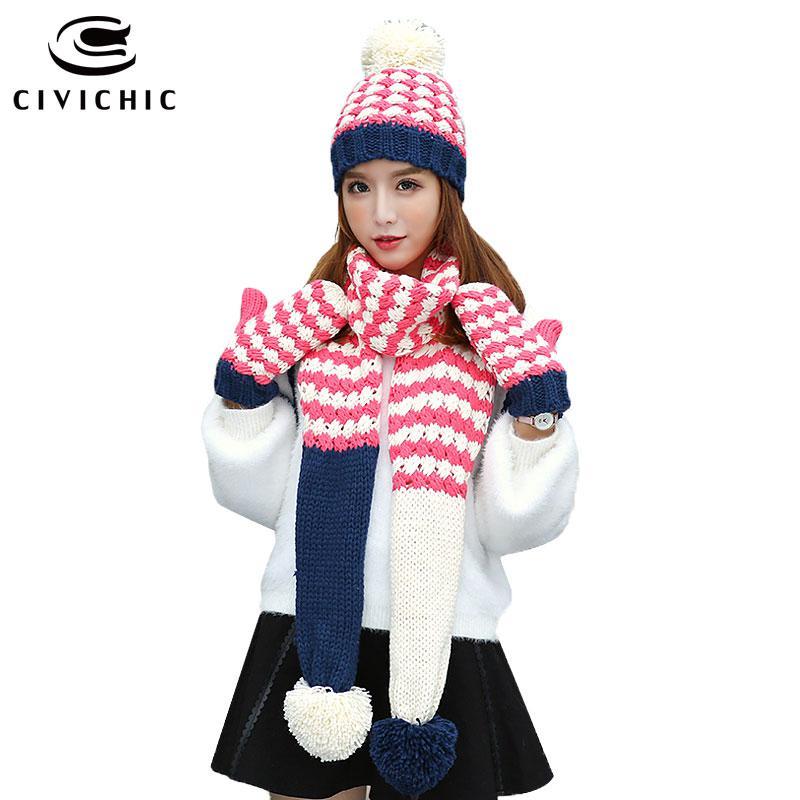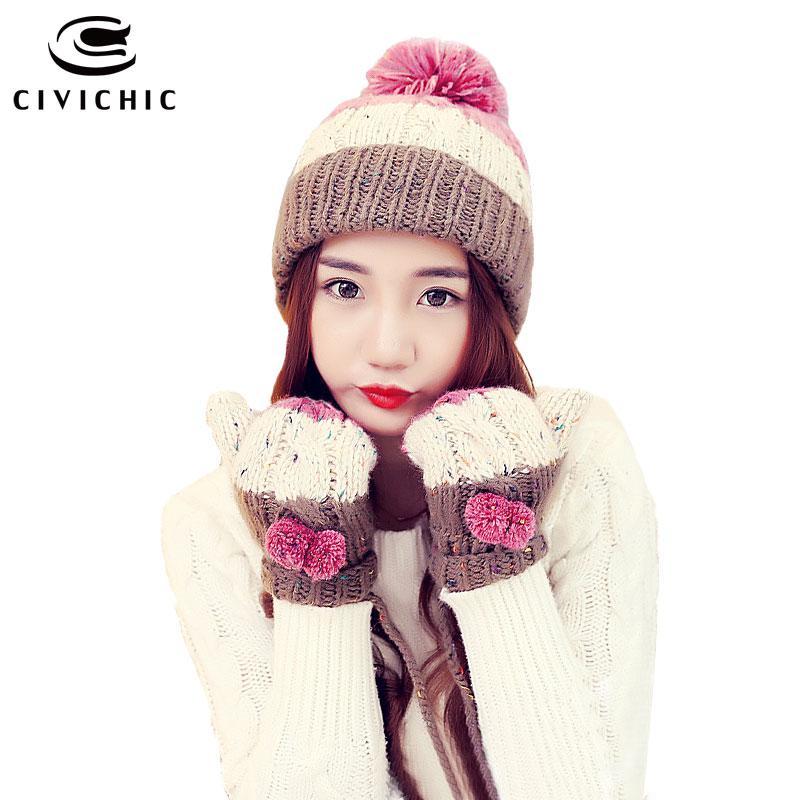The first image is the image on the left, the second image is the image on the right. Analyze the images presented: Is the assertion "The woman in the image on the left is wearing a hat and a scarf." valid? Answer yes or no. Yes. The first image is the image on the left, the second image is the image on the right. For the images shown, is this caption "The model in one image wears a hat with animal ears and coordinating mittens." true? Answer yes or no. No. 